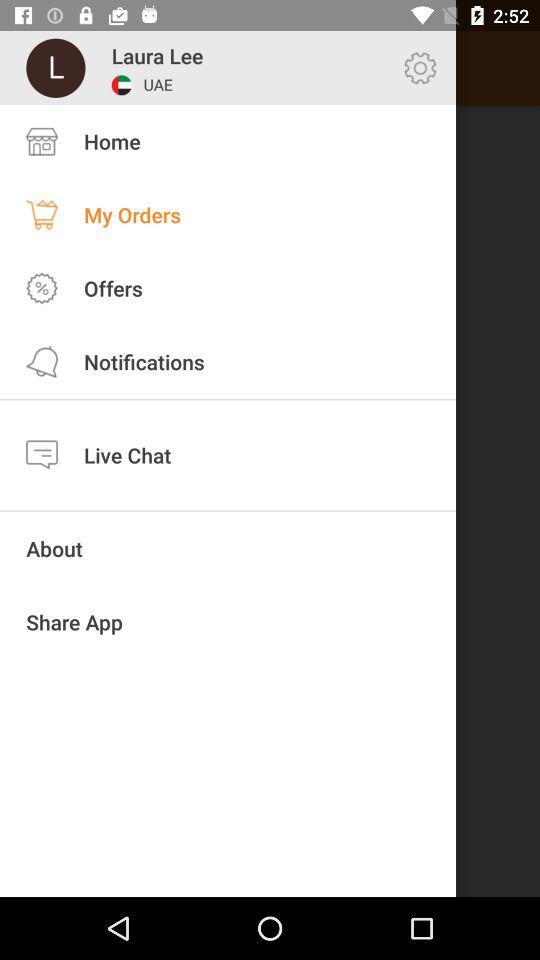What is the user name? The user name is Laura Lee. 